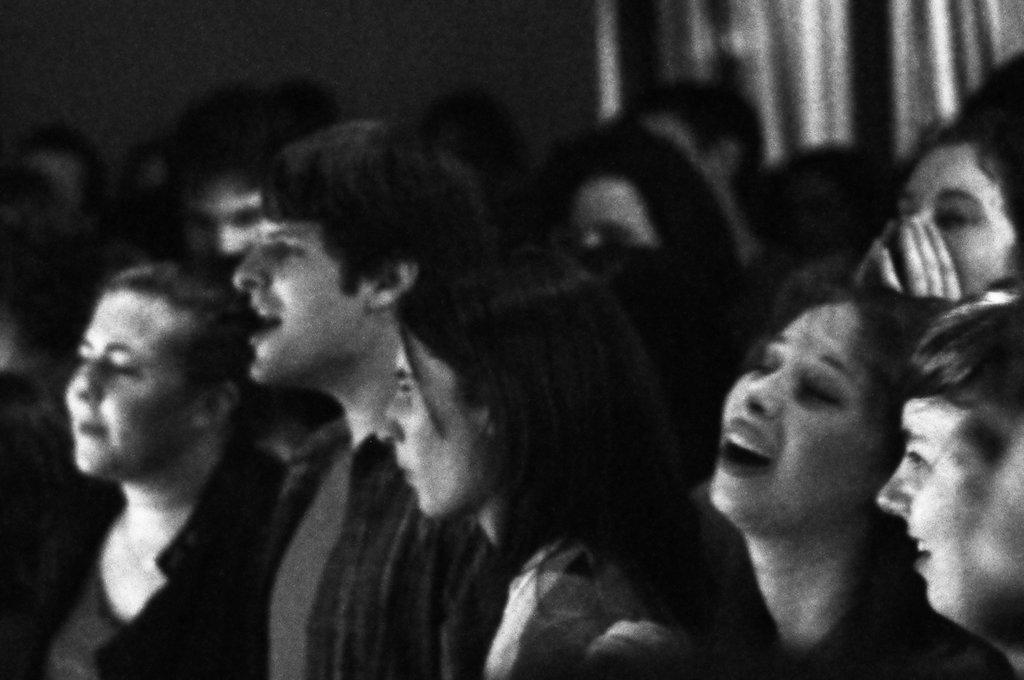What is the color scheme of the image? The image is black and white. What can be seen in the image? There is a group of people in the image. Can you describe the background of the image? The background of the image is blurred. What type of skirt is the person wearing in the image? There is no person wearing a skirt in the image, as the image is black and white and features a group of people. What rule is being enforced by the person in the image? There is no indication of any rule being enforced in the image, as it only shows a group of people and a blurred background. 